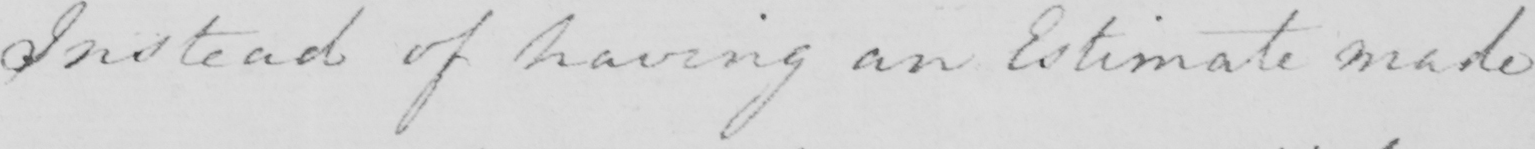Please transcribe the handwritten text in this image. Instead of having an Estimate made 